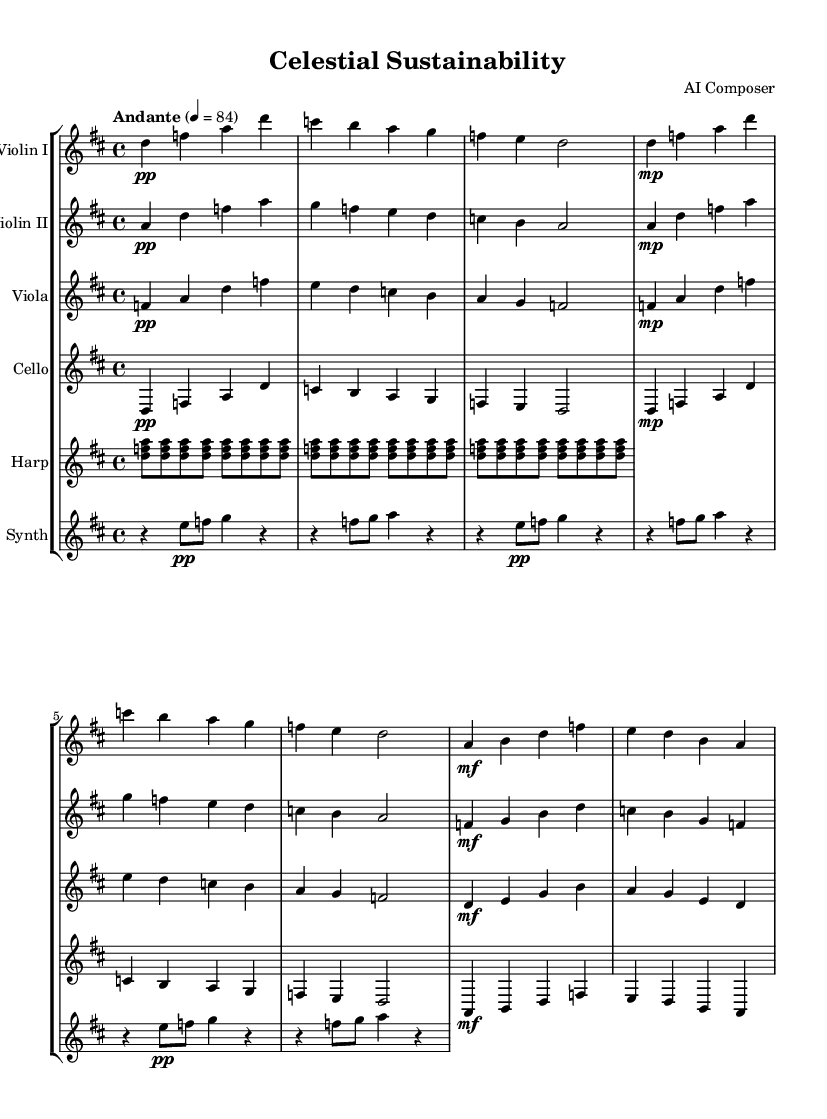What is the key signature of this music? The key signature is D major, which has two sharps (F# and C#).
Answer: D major What is the time signature of this music? The time signature is 4/4, indicating four beats per measure.
Answer: 4/4 What is the tempo marking of this composition? The tempo marking is Andante, which suggests a moderately slow pace.
Answer: Andante How many main themes are present in the score? There are two main themes: Theme A and Theme B, both labeled in the score.
Answer: Two Which instrument provides arpeggios representing solar panel arrays? The harp part includes arpeggios that symbolize solar panel arrays through repeated patterns.
Answer: Harp What dynamic marking is used at the beginning of the piece? The dynamic marking at the beginning is pianissimo (pp), indicating very soft playing.
Answer: Pianissimo Which instrument is designated for futuristic sound effects? The synthesizer is specified for creating futuristic sound effects throughout the score.
Answer: Synthesizer 